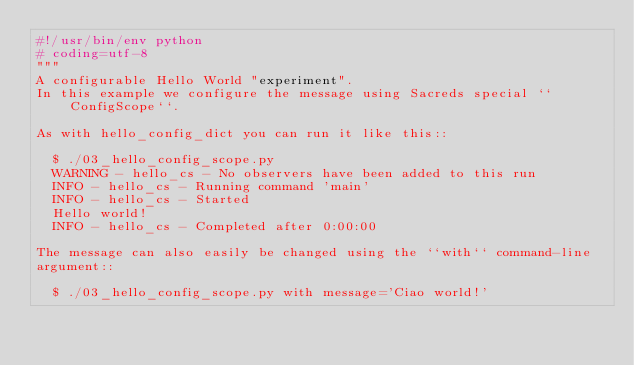Convert code to text. <code><loc_0><loc_0><loc_500><loc_500><_Python_>#!/usr/bin/env python
# coding=utf-8
"""
A configurable Hello World "experiment".
In this example we configure the message using Sacreds special ``ConfigScope``.

As with hello_config_dict you can run it like this::

  $ ./03_hello_config_scope.py
  WARNING - hello_cs - No observers have been added to this run
  INFO - hello_cs - Running command 'main'
  INFO - hello_cs - Started
  Hello world!
  INFO - hello_cs - Completed after 0:00:00

The message can also easily be changed using the ``with`` command-line
argument::

  $ ./03_hello_config_scope.py with message='Ciao world!'</code> 